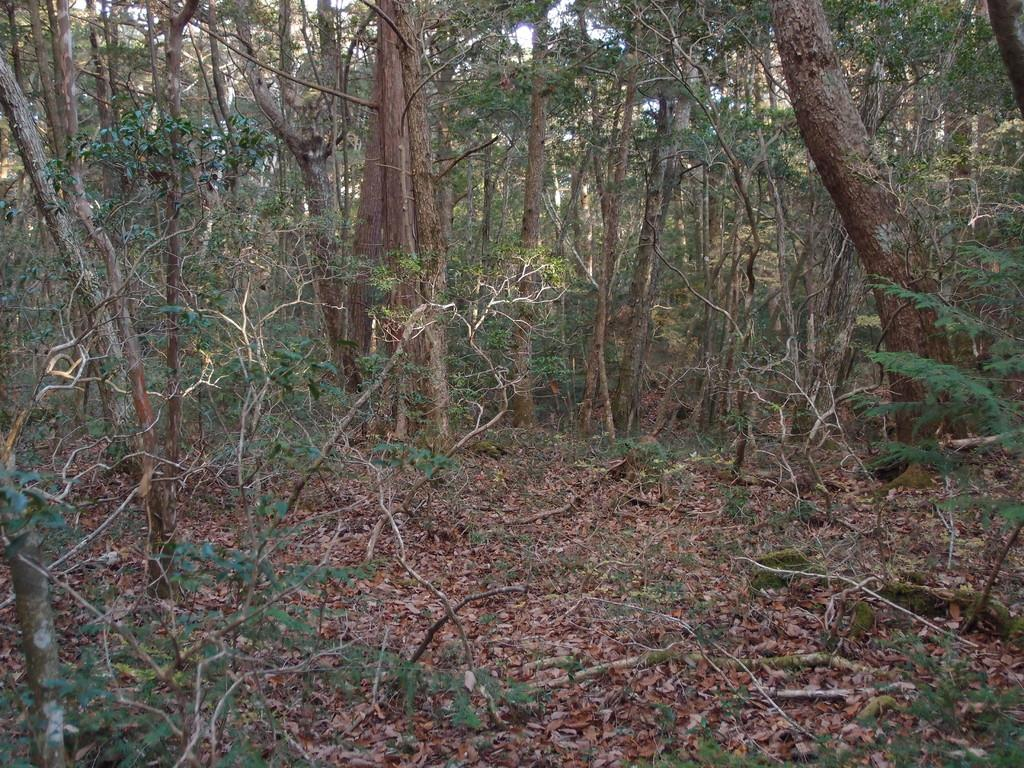What type of environment is depicted in the image? The image appears to be taken in a forest. What can be seen in the forest? There is a group of trees in the image. What is present at the bottom of the image? Dry leaves and grass are visible at the bottom of the image. What type of punishment is being carried out in the image? There is no punishment being carried out in the image; it depicts a forest setting with trees, dry leaves, and grass. What color is the bead that is hanging from the tree in the image? There is no bead present in the image; it only shows a forest setting with trees, dry leaves, and grass. 